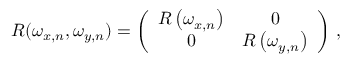Convert formula to latex. <formula><loc_0><loc_0><loc_500><loc_500>R ( \omega _ { x , n } , \omega _ { y , n } ) = \left ( \begin{array} { c c } { R \left ( \omega _ { x , n } \right ) } & { 0 } \\ { 0 } & { R \left ( \omega _ { y , n } \right ) } \end{array} \right ) \, ,</formula> 